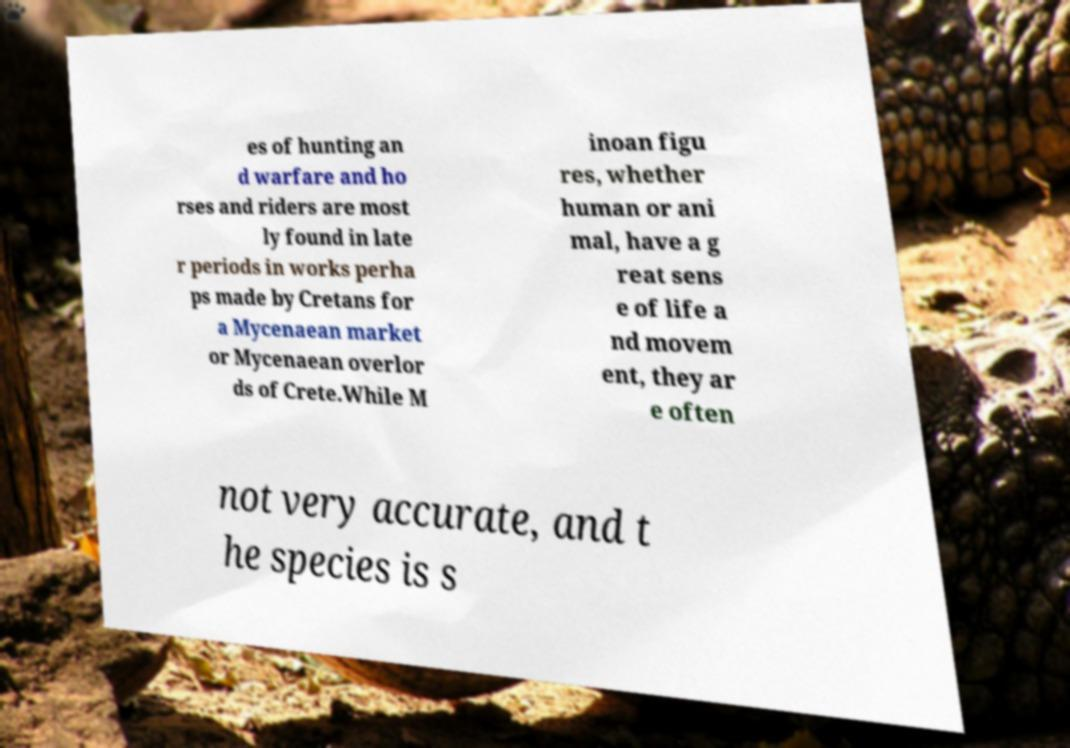I need the written content from this picture converted into text. Can you do that? es of hunting an d warfare and ho rses and riders are most ly found in late r periods in works perha ps made by Cretans for a Mycenaean market or Mycenaean overlor ds of Crete.While M inoan figu res, whether human or ani mal, have a g reat sens e of life a nd movem ent, they ar e often not very accurate, and t he species is s 